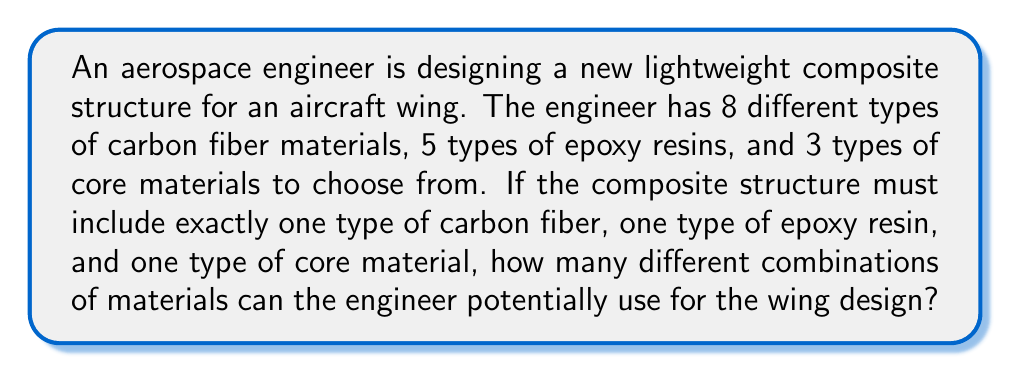Can you solve this math problem? To solve this problem, we need to use the multiplication principle of counting. This principle states that if we have a series of independent choices, where the number of ways to make each choice is fixed, then the total number of possible outcomes is the product of the number of ways to make each choice.

In this case, we have three independent choices to make:

1. Choose a carbon fiber material: There are 8 options
2. Choose an epoxy resin: There are 5 options
3. Choose a core material: There are 3 options

Each of these choices is independent of the others, meaning that the choice of one material does not affect the available choices for the other materials.

Therefore, we can calculate the total number of possible combinations as follows:

$$ \text{Total combinations} = \text{Carbon fiber options} \times \text{Epoxy resin options} \times \text{Core material options} $$

$$ \text{Total combinations} = 8 \times 5 \times 3 $$

$$ \text{Total combinations} = 120 $$

This calculation gives us the total number of unique combinations of materials that the aerospace engineer can potentially use for the wing design.
Answer: The aerospace engineer can potentially use 120 different combinations of materials for the lightweight composite structure in the aircraft wing design. 